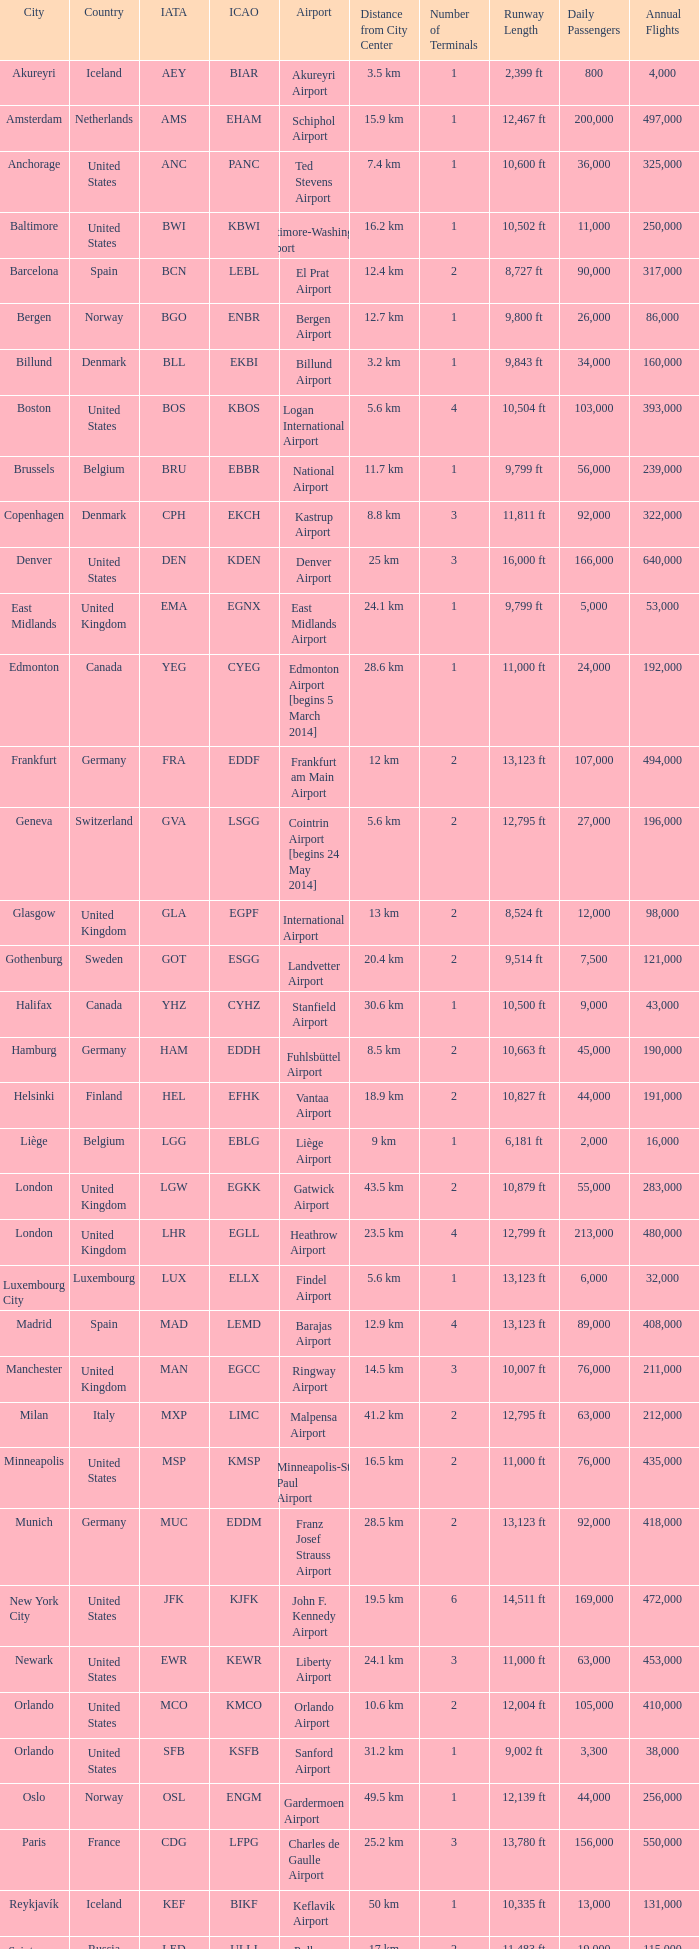What Airport's IATA is SEA? Seattle–Tacoma Airport. 